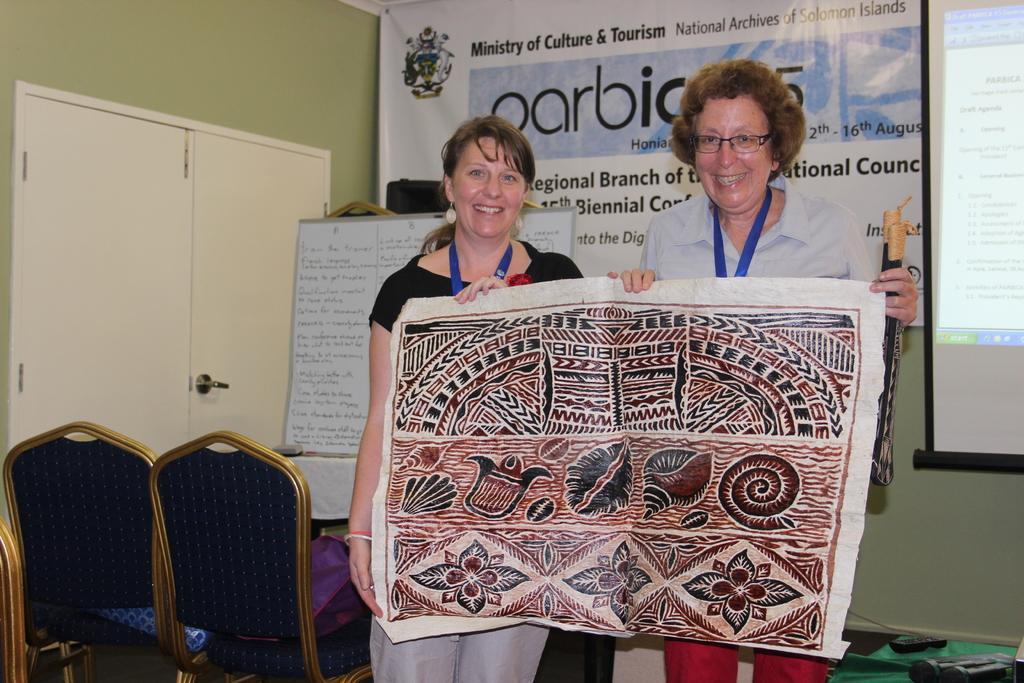Could you give a brief overview of what you see in this image? In this image consist of these are the two women standing and smiling and they are holding a painting on their hand and left side i can see a chairs and there is a door visible and on the back ground i can see a hoarding board and there are some text written on that.. On the right side corner i can see a screen. 